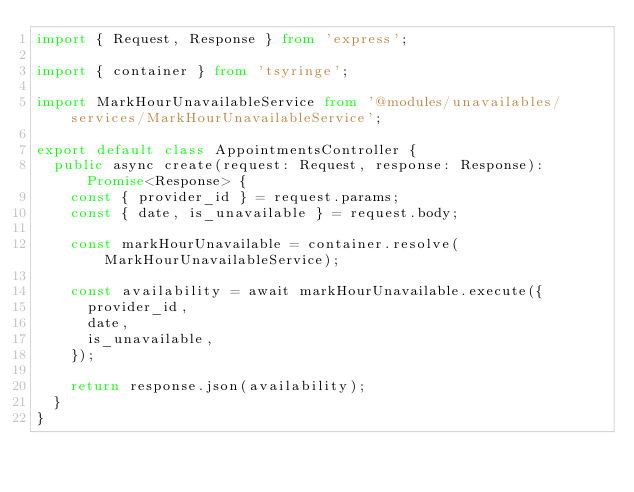<code> <loc_0><loc_0><loc_500><loc_500><_TypeScript_>import { Request, Response } from 'express';

import { container } from 'tsyringe';

import MarkHourUnavailableService from '@modules/unavailables/services/MarkHourUnavailableService';

export default class AppointmentsController {
  public async create(request: Request, response: Response): Promise<Response> {
    const { provider_id } = request.params;
    const { date, is_unavailable } = request.body;

    const markHourUnavailable = container.resolve(MarkHourUnavailableService);

    const availability = await markHourUnavailable.execute({
      provider_id,
      date,
      is_unavailable,
    });

    return response.json(availability);
  }
}
</code> 